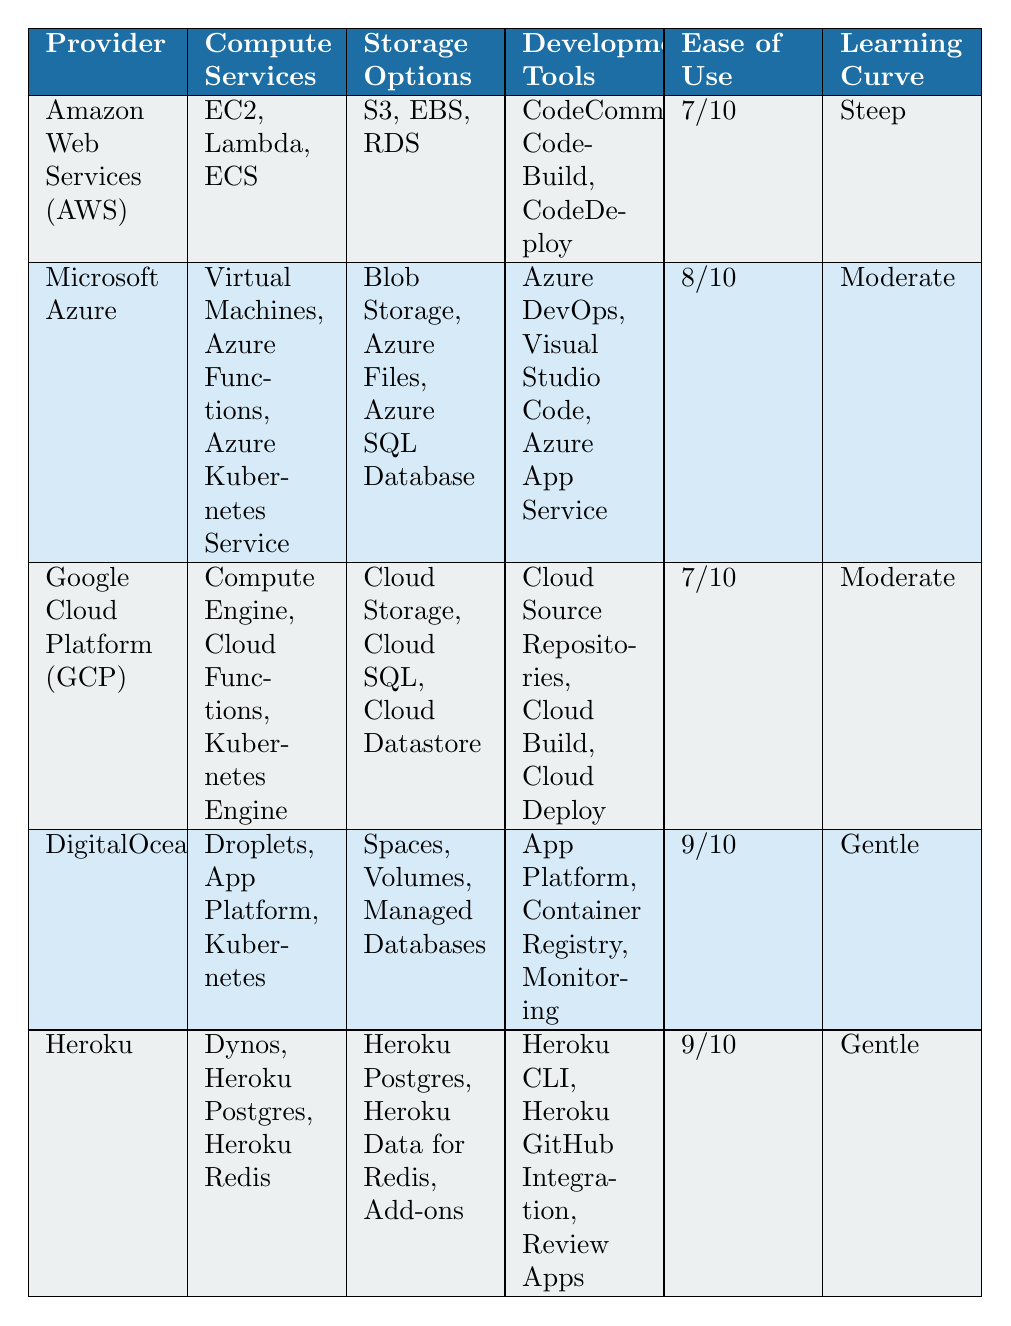What is the ease of use rating for DigitalOcean? The table shows that DigitalOcean has an ease of use rating of 9 out of 10.
Answer: 9/10 Which provider has a free trial period lasting the longest? Comparing the free trial periods listed, Amazon Web Services offers a free trial for 12 months, while the other providers offer shorter durations (30 days for Azure, 90 days for GCP, 60 days for DigitalOcean, and a free tier for Heroku). Therefore, AWS has the longest free trial period.
Answer: Amazon Web Services (AWS) What popular frameworks does Google Cloud Platform support? Reading the table, Google Cloud Platform supports the popular frameworks Go, Python, and Node.js.
Answer: Go, Python, Node.js True or False: Heroku and DigitalOcean both have a gentle learning curve. By checking the learning curve ratings, it is evident that both Heroku and DigitalOcean have a gentle learning curve. Thus, the statement is true.
Answer: True What is the average ease of use rating for all providers in the table? To find the average, we calculate the total ease of use scores: (7 + 8 + 7 + 9 + 9) = 40. Since there are 5 providers, the average is 40 divided by 5, which equals 8.
Answer: 8 Which provider has the most development tools listed? By examining the development tools for each provider, AWS has 3, Azure has 3, GCP has 3, DigitalOcean has 3, and Heroku has 3 as well. They all are equal concerning the number of development tools listed.
Answer: None, all have 3 What are the storage options available with Microsoft Azure? The table indicates that Microsoft Azure offers Blob Storage, Azure Files, and Azure SQL Database as its storage options.
Answer: Blob Storage, Azure Files, Azure SQL Database Which provider has a simple and predictable pricing model? Only DigitalOcean is listed in the table with a simple, predictable pricing model, while the others use a pay-as-you-go pricing structure or mention free tiers.
Answer: DigitalOcean 